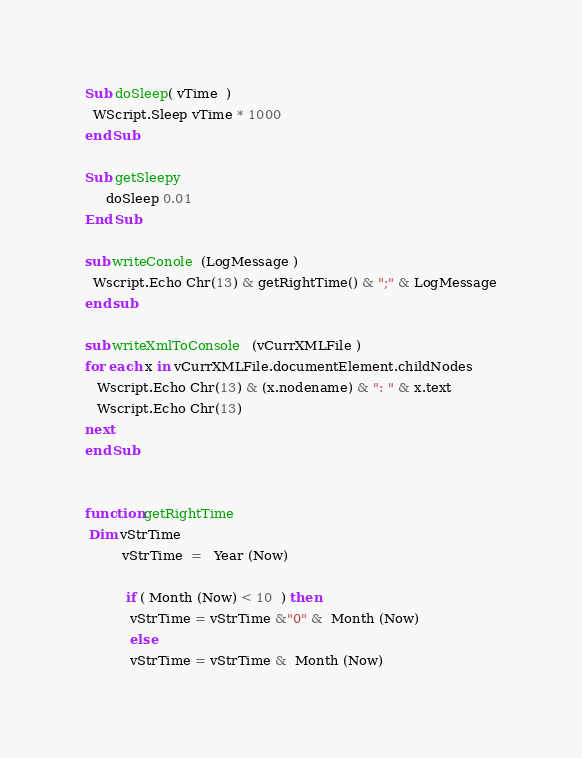<code> <loc_0><loc_0><loc_500><loc_500><_VisualBasic_>Sub doSleep( vTime  )
  WScript.Sleep vTime * 1000
end Sub

Sub getSleepy
	 doSleep 0.01 
End Sub 

sub writeConole  (LogMessage )
  Wscript.Echo Chr(13) & getRightTime() & ";" & LogMessage
end sub

sub writeXmlToConsole   (vCurrXMLFile ) 
for each x in vCurrXMLFile.documentElement.childNodes
   Wscript.Echo Chr(13) & (x.nodename) & ": " & x.text
   Wscript.Echo Chr(13) 
next
end Sub 
 

function getRightTime 
 Dim vStrTime 
		 vStrTime  =   Year (Now)

		  if ( Month (Now) < 10  ) then 
		   vStrTime = vStrTime &"0" &  Month (Now)
		   else 
		   vStrTime = vStrTime &  Month (Now)</code> 